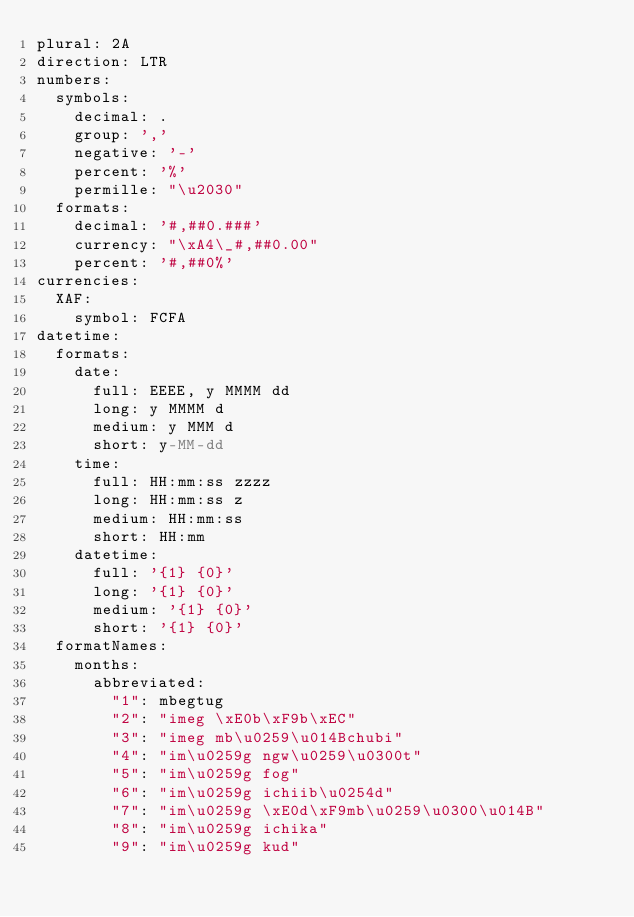Convert code to text. <code><loc_0><loc_0><loc_500><loc_500><_YAML_>plural: 2A
direction: LTR
numbers:
  symbols:
    decimal: .
    group: ','
    negative: '-'
    percent: '%'
    permille: "\u2030"
  formats:
    decimal: '#,##0.###'
    currency: "\xA4\_#,##0.00"
    percent: '#,##0%'
currencies:
  XAF:
    symbol: FCFA
datetime:
  formats:
    date:
      full: EEEE, y MMMM dd
      long: y MMMM d
      medium: y MMM d
      short: y-MM-dd
    time:
      full: HH:mm:ss zzzz
      long: HH:mm:ss z
      medium: HH:mm:ss
      short: HH:mm
    datetime:
      full: '{1} {0}'
      long: '{1} {0}'
      medium: '{1} {0}'
      short: '{1} {0}'
  formatNames:
    months:
      abbreviated:
        "1": mbegtug
        "2": "imeg \xE0b\xF9b\xEC"
        "3": "imeg mb\u0259\u014Bchubi"
        "4": "im\u0259g ngw\u0259\u0300t"
        "5": "im\u0259g fog"
        "6": "im\u0259g ichiib\u0254d"
        "7": "im\u0259g \xE0d\xF9mb\u0259\u0300\u014B"
        "8": "im\u0259g ichika"
        "9": "im\u0259g kud"</code> 